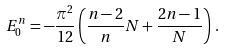Convert formula to latex. <formula><loc_0><loc_0><loc_500><loc_500>E _ { 0 } ^ { n } = - \frac { \pi ^ { 2 } } { 1 2 } \left ( \frac { n - 2 } { n } N + \frac { 2 n - 1 } { N } \right ) \, .</formula> 